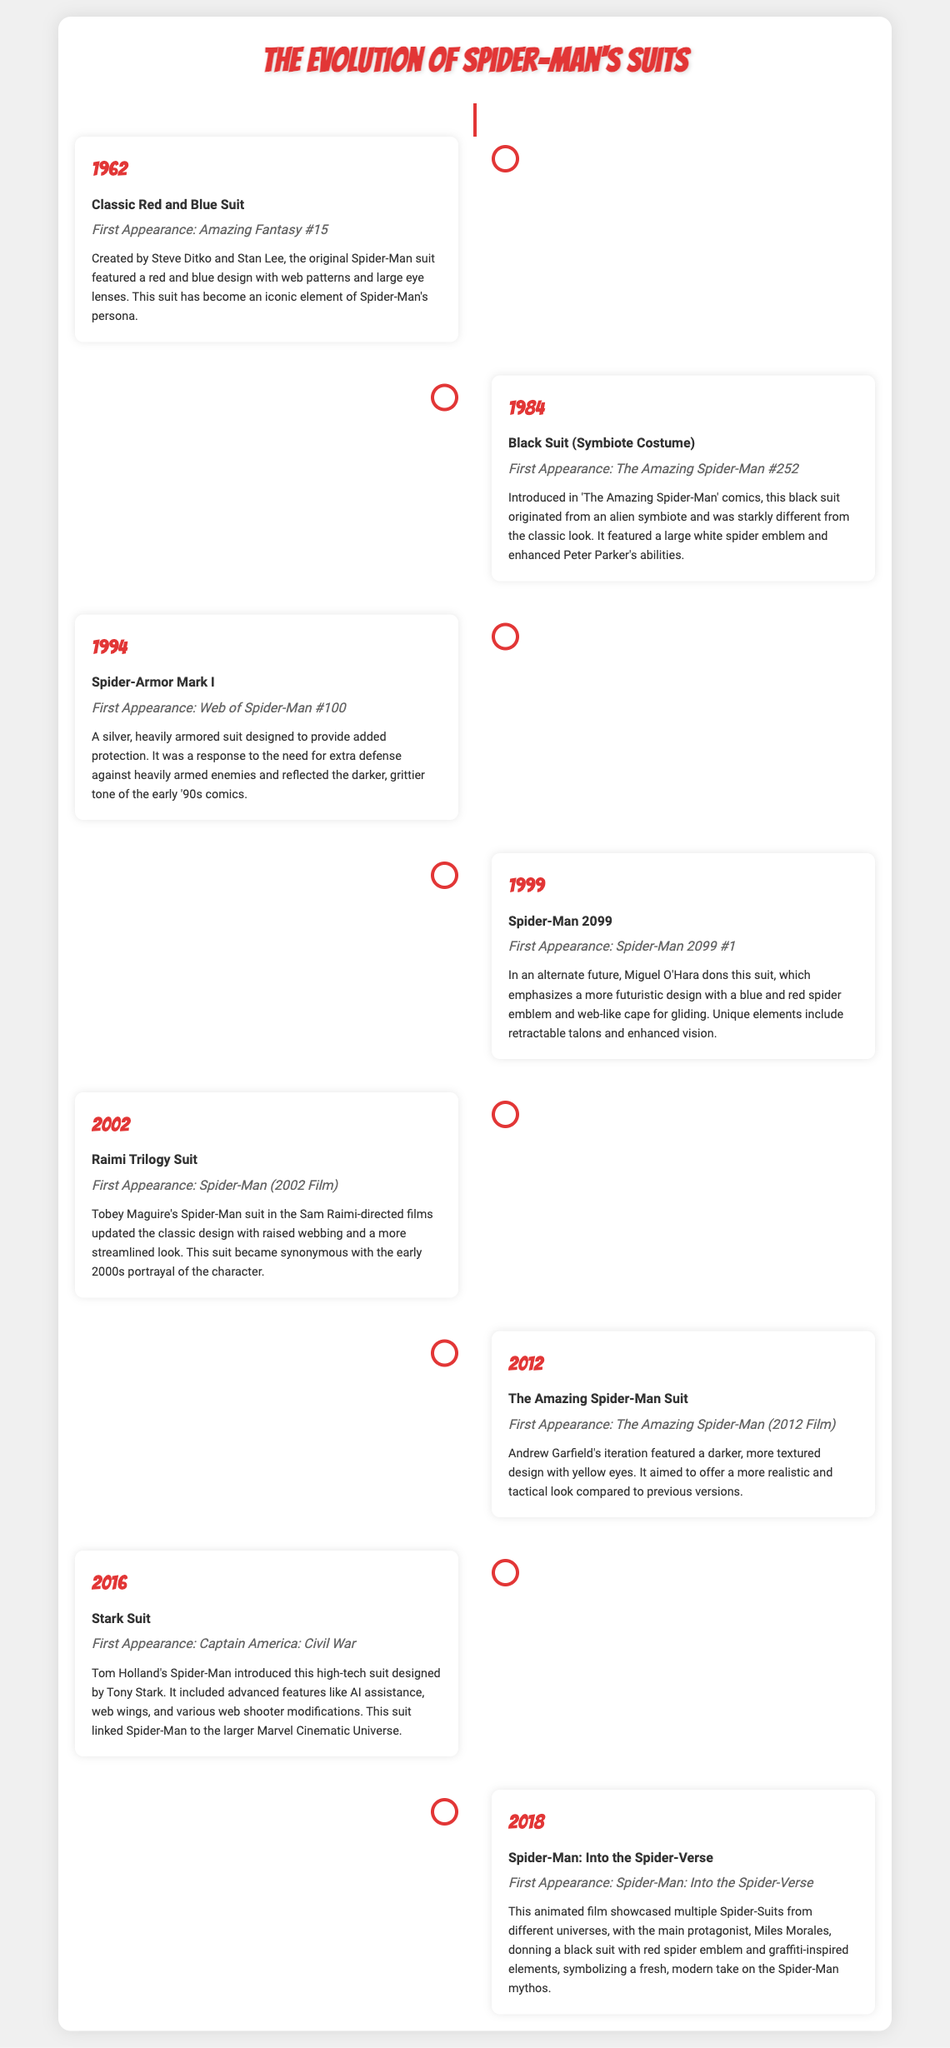What year was the Classic Red and Blue Suit introduced? The Classic Red and Blue Suit was first introduced in 1962.
Answer: 1962 Who is credited with creating the Classic Red and Blue Suit? The suit was created by Steve Ditko and Stan Lee.
Answer: Steve Ditko and Stan Lee What is the first appearance of the Black Suit (Symbiote Costume)? The Black Suit first appeared in The Amazing Spider-Man #252.
Answer: The Amazing Spider-Man #252 Which suit features AI assistance and web wings? The Stark Suit includes advanced features like AI assistance and web wings.
Answer: Stark Suit How many Spider-Man suits are shown in the timeline from 1962 to 2018? There are a total of 8 Spider-Man suits depicted in the timeline.
Answer: 8 What color scheme is predominant in Spider-Man 2099's suit? The Spider-Man 2099 suit emphasizes blue and red colors.
Answer: Blue and red Which suit introduced a more realistic and tactical look? The Amazing Spider-Man Suit aimed for a realistic and tactical look.
Answer: The Amazing Spider-Man Suit What film features Tobey Maguire's Spider-Man suit? The Raimi Trilogy Suit first appears in Spider-Man (2002 Film).
Answer: Spider-Man (2002 Film) What year was the Stark Suit introduced? The Stark Suit was introduced in 2016.
Answer: 2016 